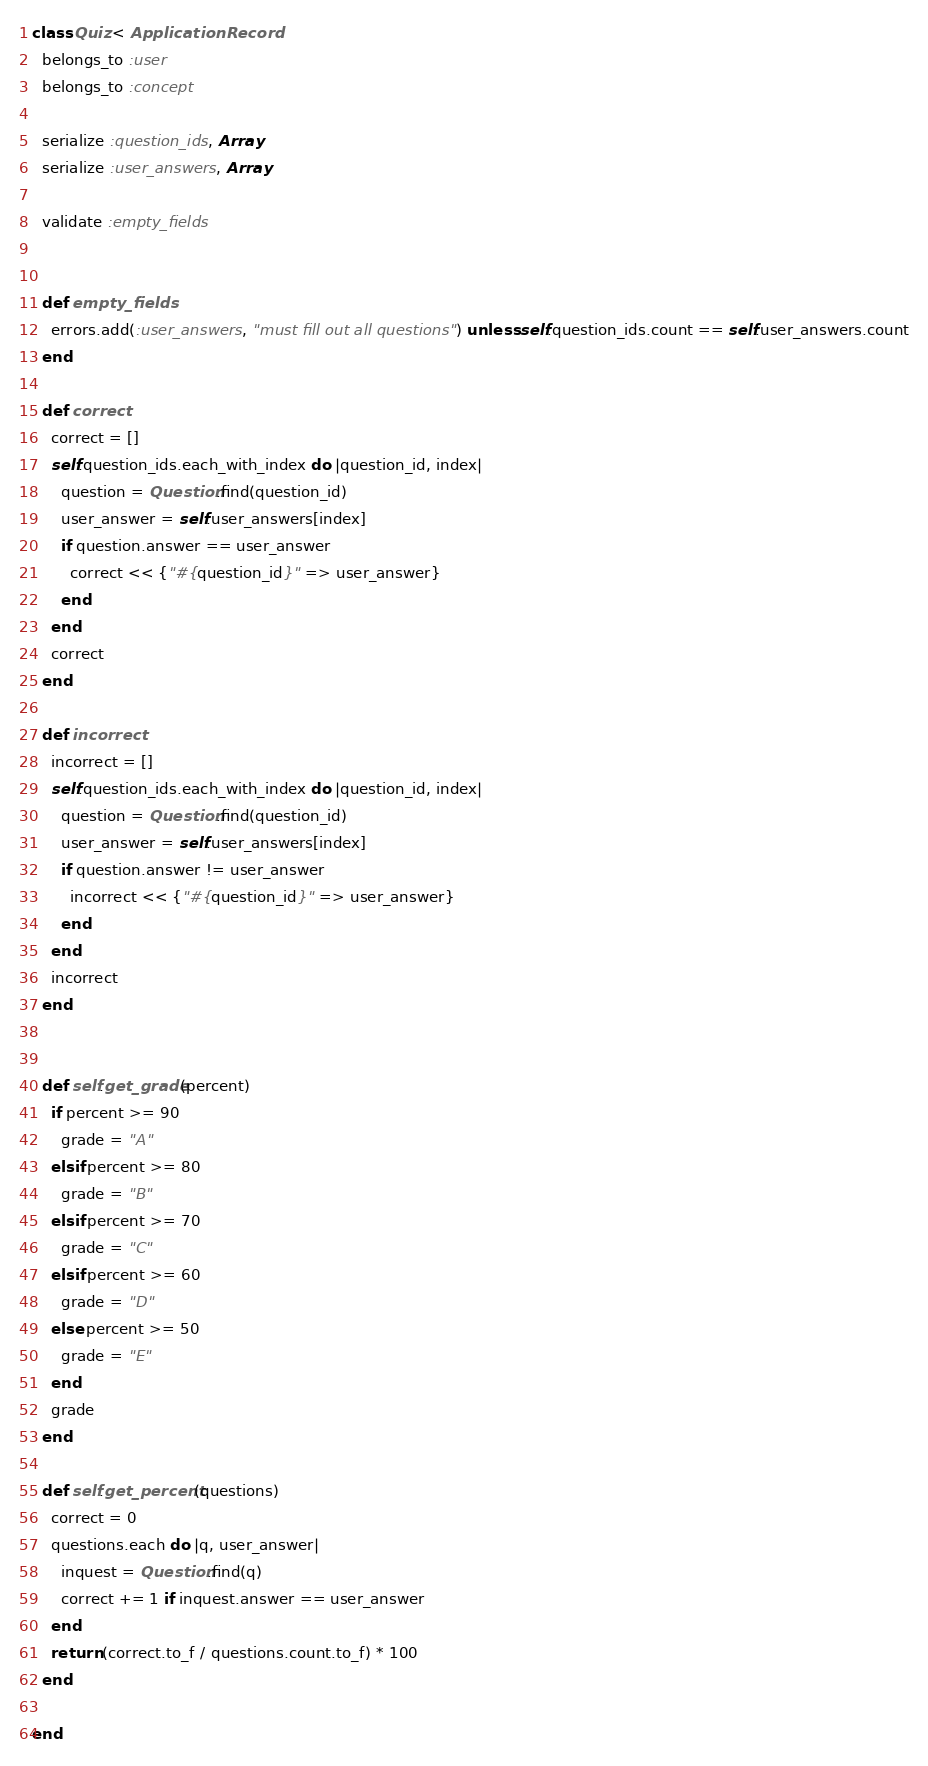<code> <loc_0><loc_0><loc_500><loc_500><_Ruby_>class Quiz < ApplicationRecord
  belongs_to :user
  belongs_to :concept

  serialize :question_ids, Array
  serialize :user_answers, Array

  validate :empty_fields


  def empty_fields
    errors.add(:user_answers, "must fill out all questions") unless self.question_ids.count == self.user_answers.count
  end

  def correct
    correct = []
    self.question_ids.each_with_index do |question_id, index|
      question = Question.find(question_id)
      user_answer = self.user_answers[index]
      if question.answer == user_answer
        correct << {"#{question_id}" => user_answer}
      end
    end
    correct
  end

  def incorrect
    incorrect = []
    self.question_ids.each_with_index do |question_id, index|
      question = Question.find(question_id)
      user_answer = self.user_answers[index]
      if question.answer != user_answer
        incorrect << {"#{question_id}" => user_answer}
      end
    end
    incorrect
  end


  def self.get_grade(percent)
    if percent >= 90
      grade = "A"
    elsif percent >= 80
      grade = "B"
    elsif percent >= 70
      grade = "C"
    elsif percent >= 60
      grade = "D"
    else percent >= 50
      grade = "E"
    end
    grade
  end

  def self.get_percent(questions)
    correct = 0
    questions.each do |q, user_answer|
      inquest = Question.find(q)
      correct += 1 if inquest.answer == user_answer
    end
    return (correct.to_f / questions.count.to_f) * 100
  end

end
</code> 